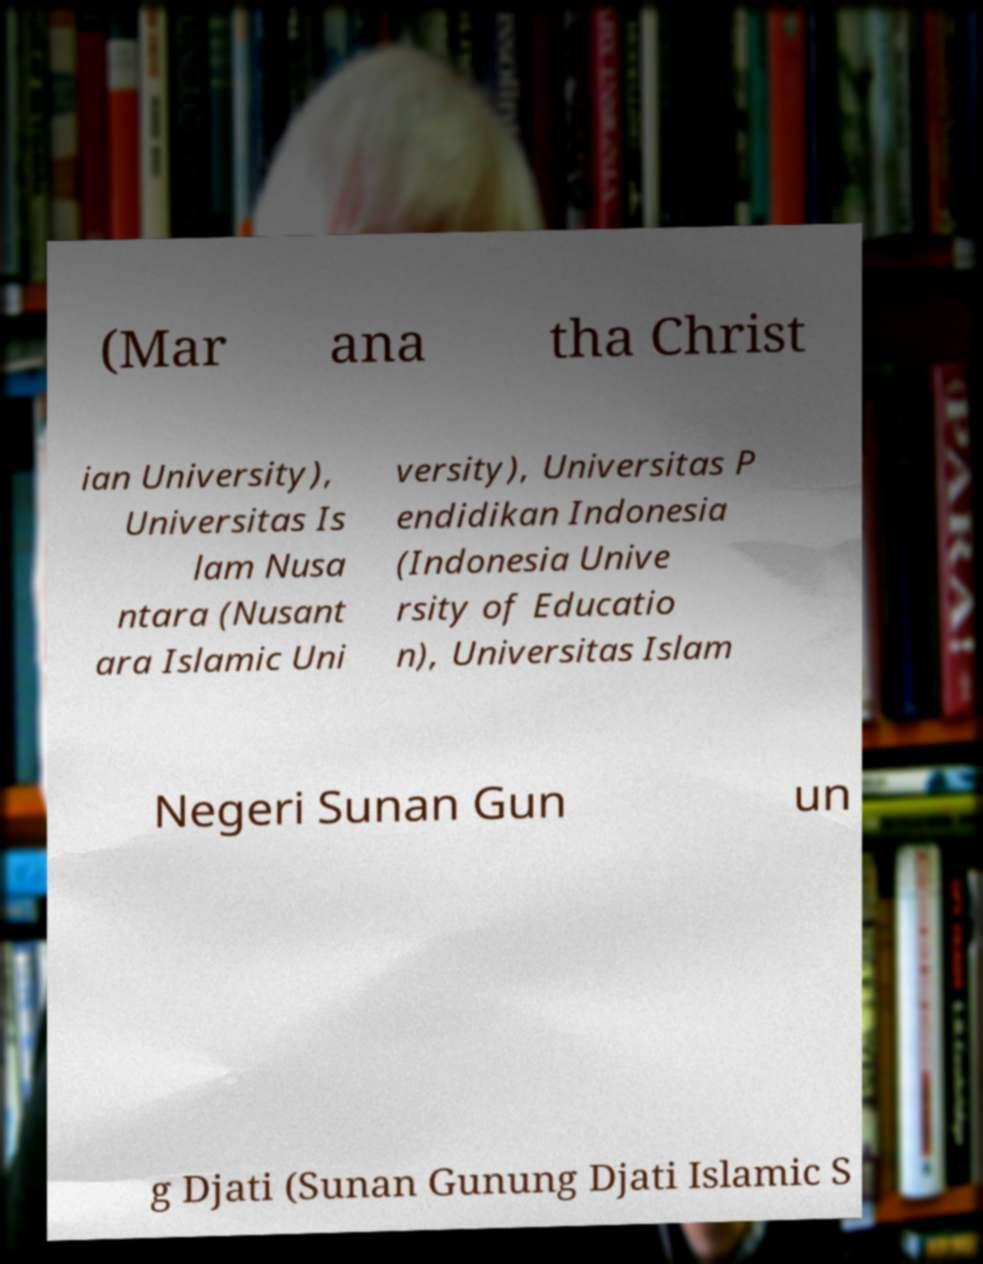I need the written content from this picture converted into text. Can you do that? (Mar ana tha Christ ian University), Universitas Is lam Nusa ntara (Nusant ara Islamic Uni versity), Universitas P endidikan Indonesia (Indonesia Unive rsity of Educatio n), Universitas Islam Negeri Sunan Gun un g Djati (Sunan Gunung Djati Islamic S 